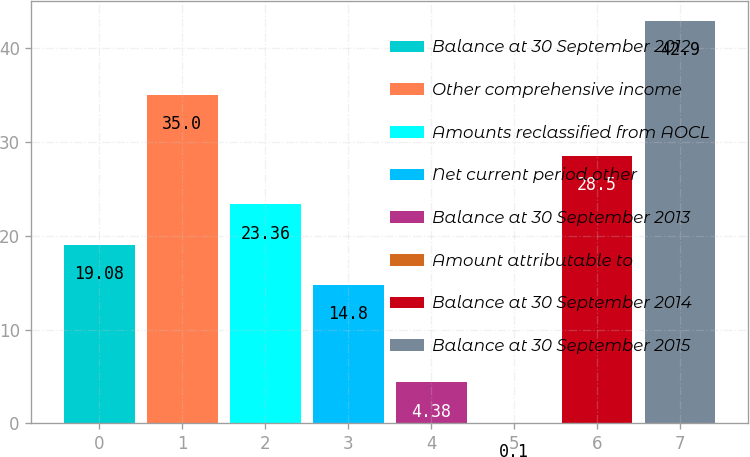<chart> <loc_0><loc_0><loc_500><loc_500><bar_chart><fcel>Balance at 30 September 2012<fcel>Other comprehensive income<fcel>Amounts reclassified from AOCL<fcel>Net current period other<fcel>Balance at 30 September 2013<fcel>Amount attributable to<fcel>Balance at 30 September 2014<fcel>Balance at 30 September 2015<nl><fcel>19.08<fcel>35<fcel>23.36<fcel>14.8<fcel>4.38<fcel>0.1<fcel>28.5<fcel>42.9<nl></chart> 